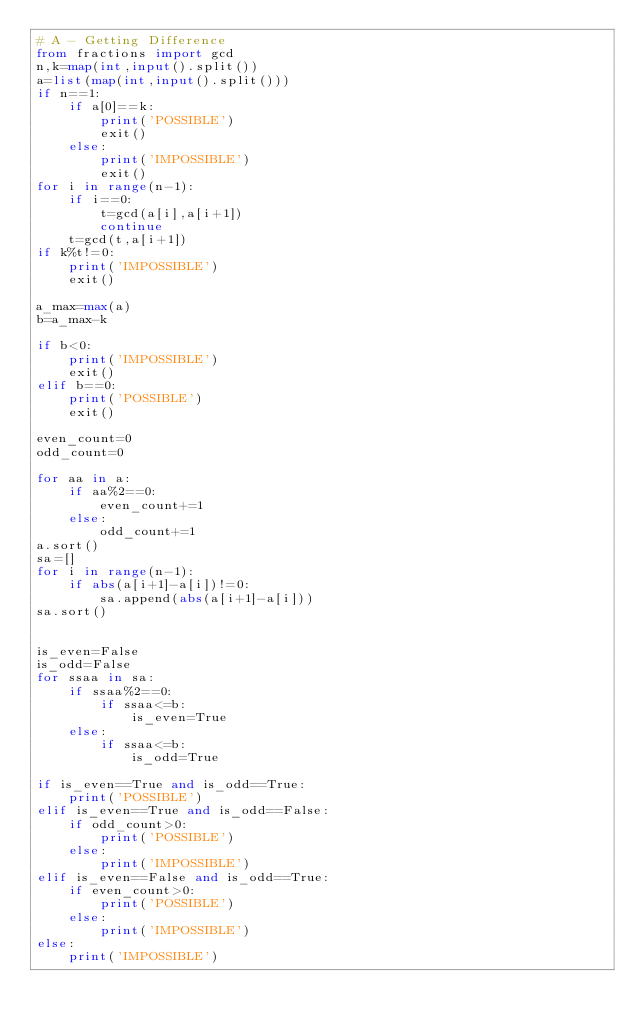Convert code to text. <code><loc_0><loc_0><loc_500><loc_500><_Python_># A - Getting Difference
from fractions import gcd
n,k=map(int,input().split())
a=list(map(int,input().split()))
if n==1:
    if a[0]==k:
        print('POSSIBLE')
        exit()
    else:
        print('IMPOSSIBLE')    
        exit()
for i in range(n-1):
    if i==0:
        t=gcd(a[i],a[i+1])
        continue
    t=gcd(t,a[i+1])
if k%t!=0:
    print('IMPOSSIBLE')
    exit()

a_max=max(a)
b=a_max-k

if b<0:
    print('IMPOSSIBLE')
    exit()
elif b==0:
    print('POSSIBLE')
    exit()

even_count=0
odd_count=0

for aa in a:
    if aa%2==0:
        even_count+=1
    else:
        odd_count+=1
a.sort()
sa=[]
for i in range(n-1):
    if abs(a[i+1]-a[i])!=0:
        sa.append(abs(a[i+1]-a[i]))
sa.sort()


is_even=False
is_odd=False
for ssaa in sa:
    if ssaa%2==0:
        if ssaa<=b:
            is_even=True
    else:
        if ssaa<=b:
            is_odd=True

if is_even==True and is_odd==True:
    print('POSSIBLE')
elif is_even==True and is_odd==False:
    if odd_count>0:
        print('POSSIBLE')
    else:
        print('IMPOSSIBLE')
elif is_even==False and is_odd==True:
    if even_count>0:
        print('POSSIBLE')
    else:
        print('IMPOSSIBLE')
else:
    print('IMPOSSIBLE')</code> 